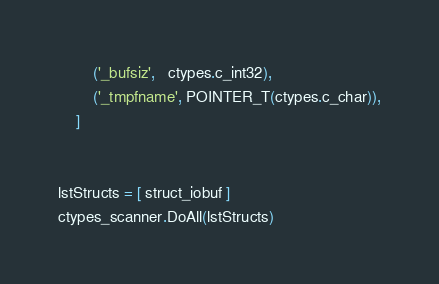Convert code to text. <code><loc_0><loc_0><loc_500><loc_500><_Python_>		('_bufsiz',   ctypes.c_int32),
		('_tmpfname', POINTER_T(ctypes.c_char)),
	]


lstStructs = [ struct_iobuf ]
ctypes_scanner.DoAll(lstStructs)</code> 